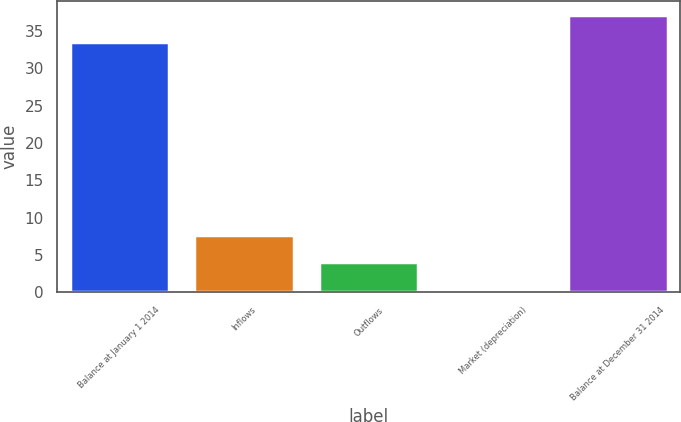Convert chart to OTSL. <chart><loc_0><loc_0><loc_500><loc_500><bar_chart><fcel>Balance at January 1 2014<fcel>Inflows<fcel>Outflows<fcel>Market (depreciation)<fcel>Balance at December 31 2014<nl><fcel>33.5<fcel>7.72<fcel>4.06<fcel>0.4<fcel>37.16<nl></chart> 